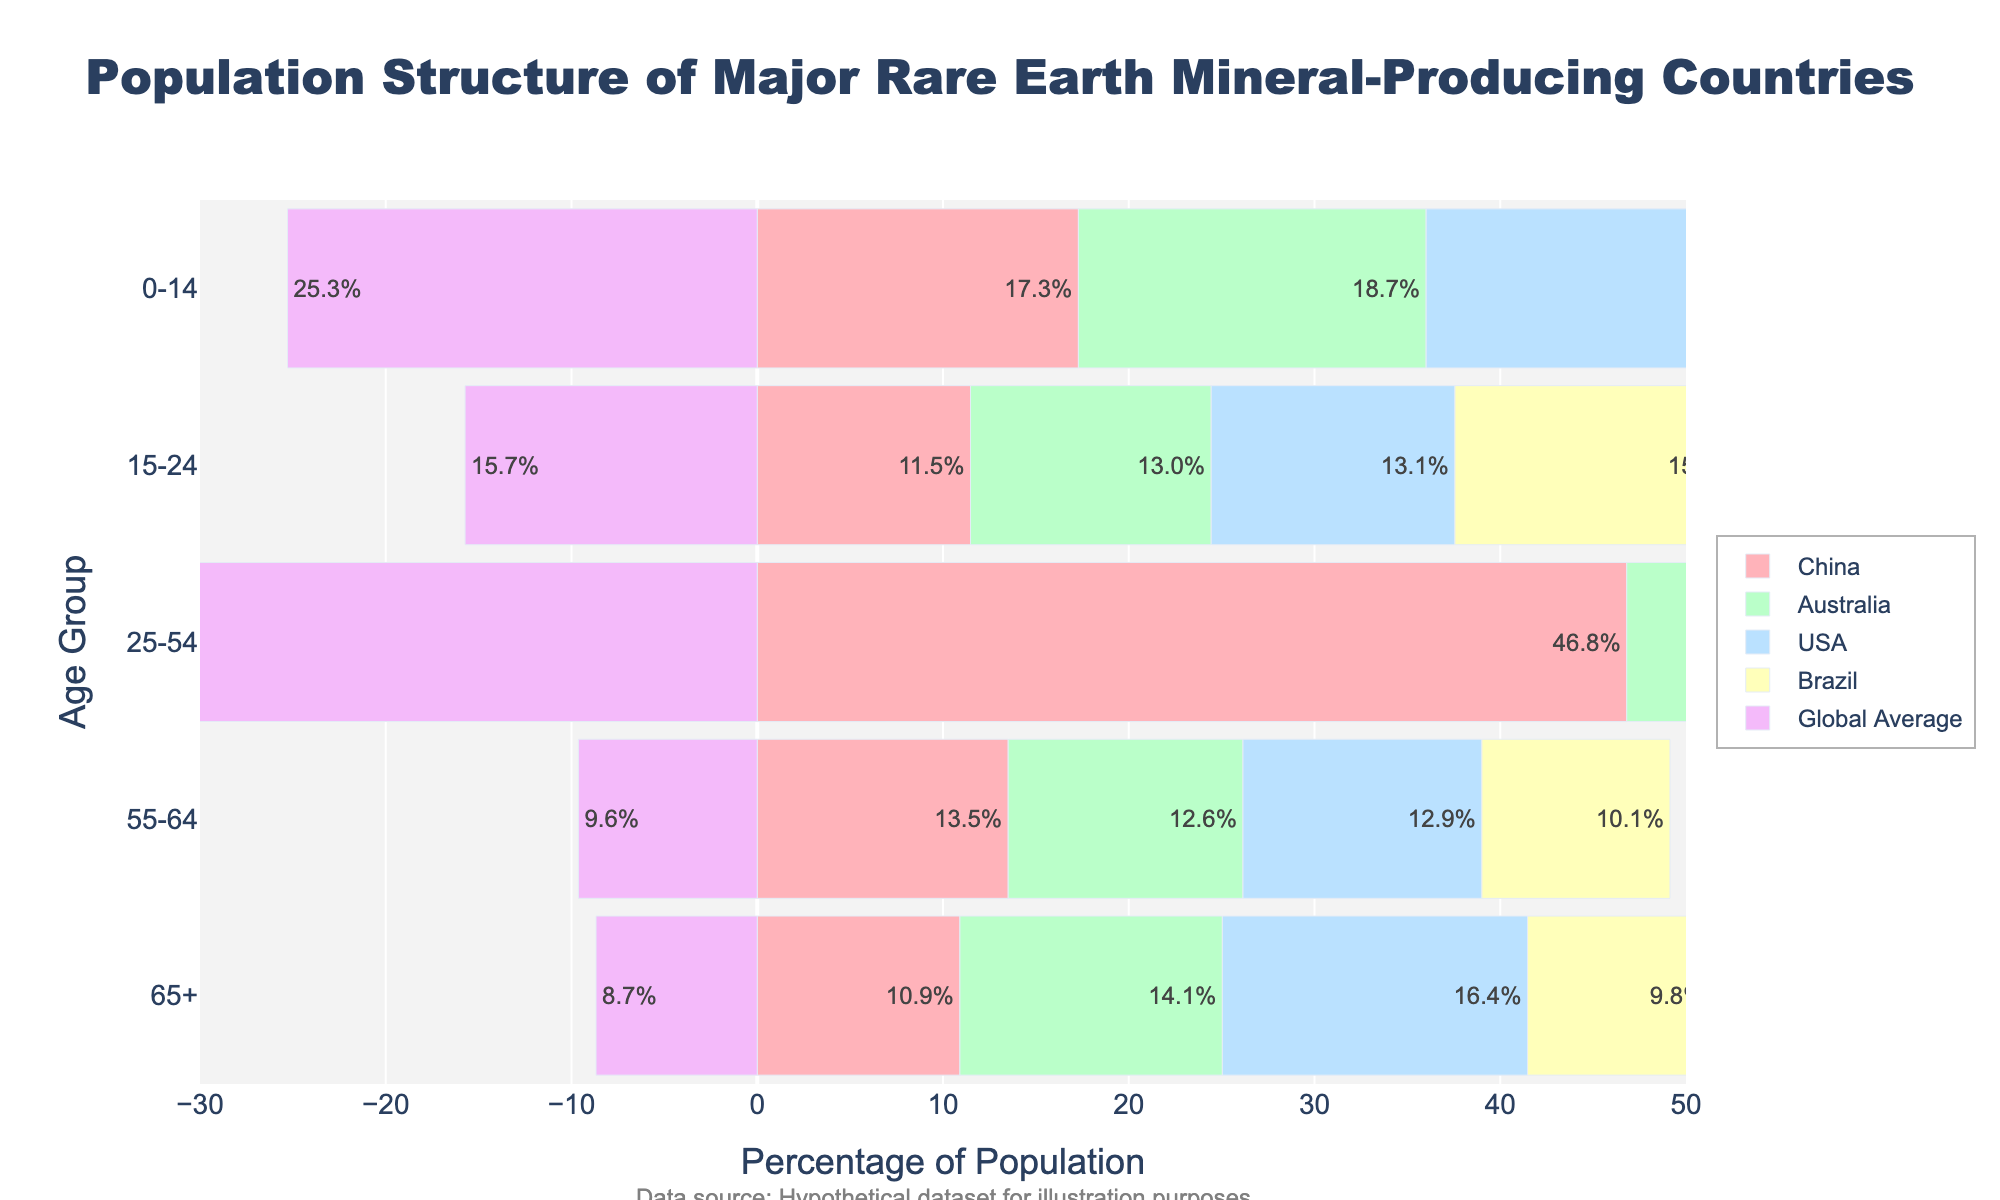1. What is the title of the figure? The title of the figure is shown at the top of the plot.
Answer: Population Structure of Major Rare Earth Mineral-Producing Countries 2. Which age group has the highest percentage of the population globally? Look at the 'Global Average' bars and identify the segment with the largest value.
Answer: 25-54 3. In which age group does China have the smallest population percentage? Check the bar for China with the smallest length.
Answer: 65+ 4. How does the population structure of the 55-64 age group in Australia compare to China? Compare the lengths of the bars for the 55-64 age group in Australia and China. Australia's bar is slightly shorter than China's.
Answer: Australia has a smaller percentage than China 5. What is the combined percentage of the population for the 0-14 and 15-24 age groups in the USA? Add the percentages for the 0-14 and 15-24 age groups in the USA: 18.37% + 13.12%.
Answer: 31.49% 6. Which country has the highest percentage of people aged 65 and above? Compare the values for the 65+ age group among all countries. The USA has the highest value at 16.43%.
Answer: USA 7. How does Brazil's population structure for the 25-54 age group compare to the global average? Compare the lengths of the bars for Brazil and the Global Average for the 25-54 age group. Brazil's value (43.86%) is higher than the global average (40.67%).
Answer: Brazil has a higher percentage than the global average 8. Is there any country with a higher population percentage in the 0-14 age group than the global average? Look for any country whose 0-14 age group bar exceeds the Global Average bar. None of the countries have a higher percentage in this group than the global average (25.29%).
Answer: No 9. What is the difference in the population percentage of the 65+ age group between Australia and Brazil? Subtract Brazil's 65+ percentage (9.85%) from Australia's (14.13%).
Answer: 4.28% 10. What can you infer about the population structure of China compared to the United States across all age groups? Examine the bars for China and the USA across all age groups. China has higher percentages in the 0-14 and 25-54 age groups but lower in the 15-24, 55-64, and 65+ age groups compared to the USA.
Answer: China has a younger population structure than the USA 